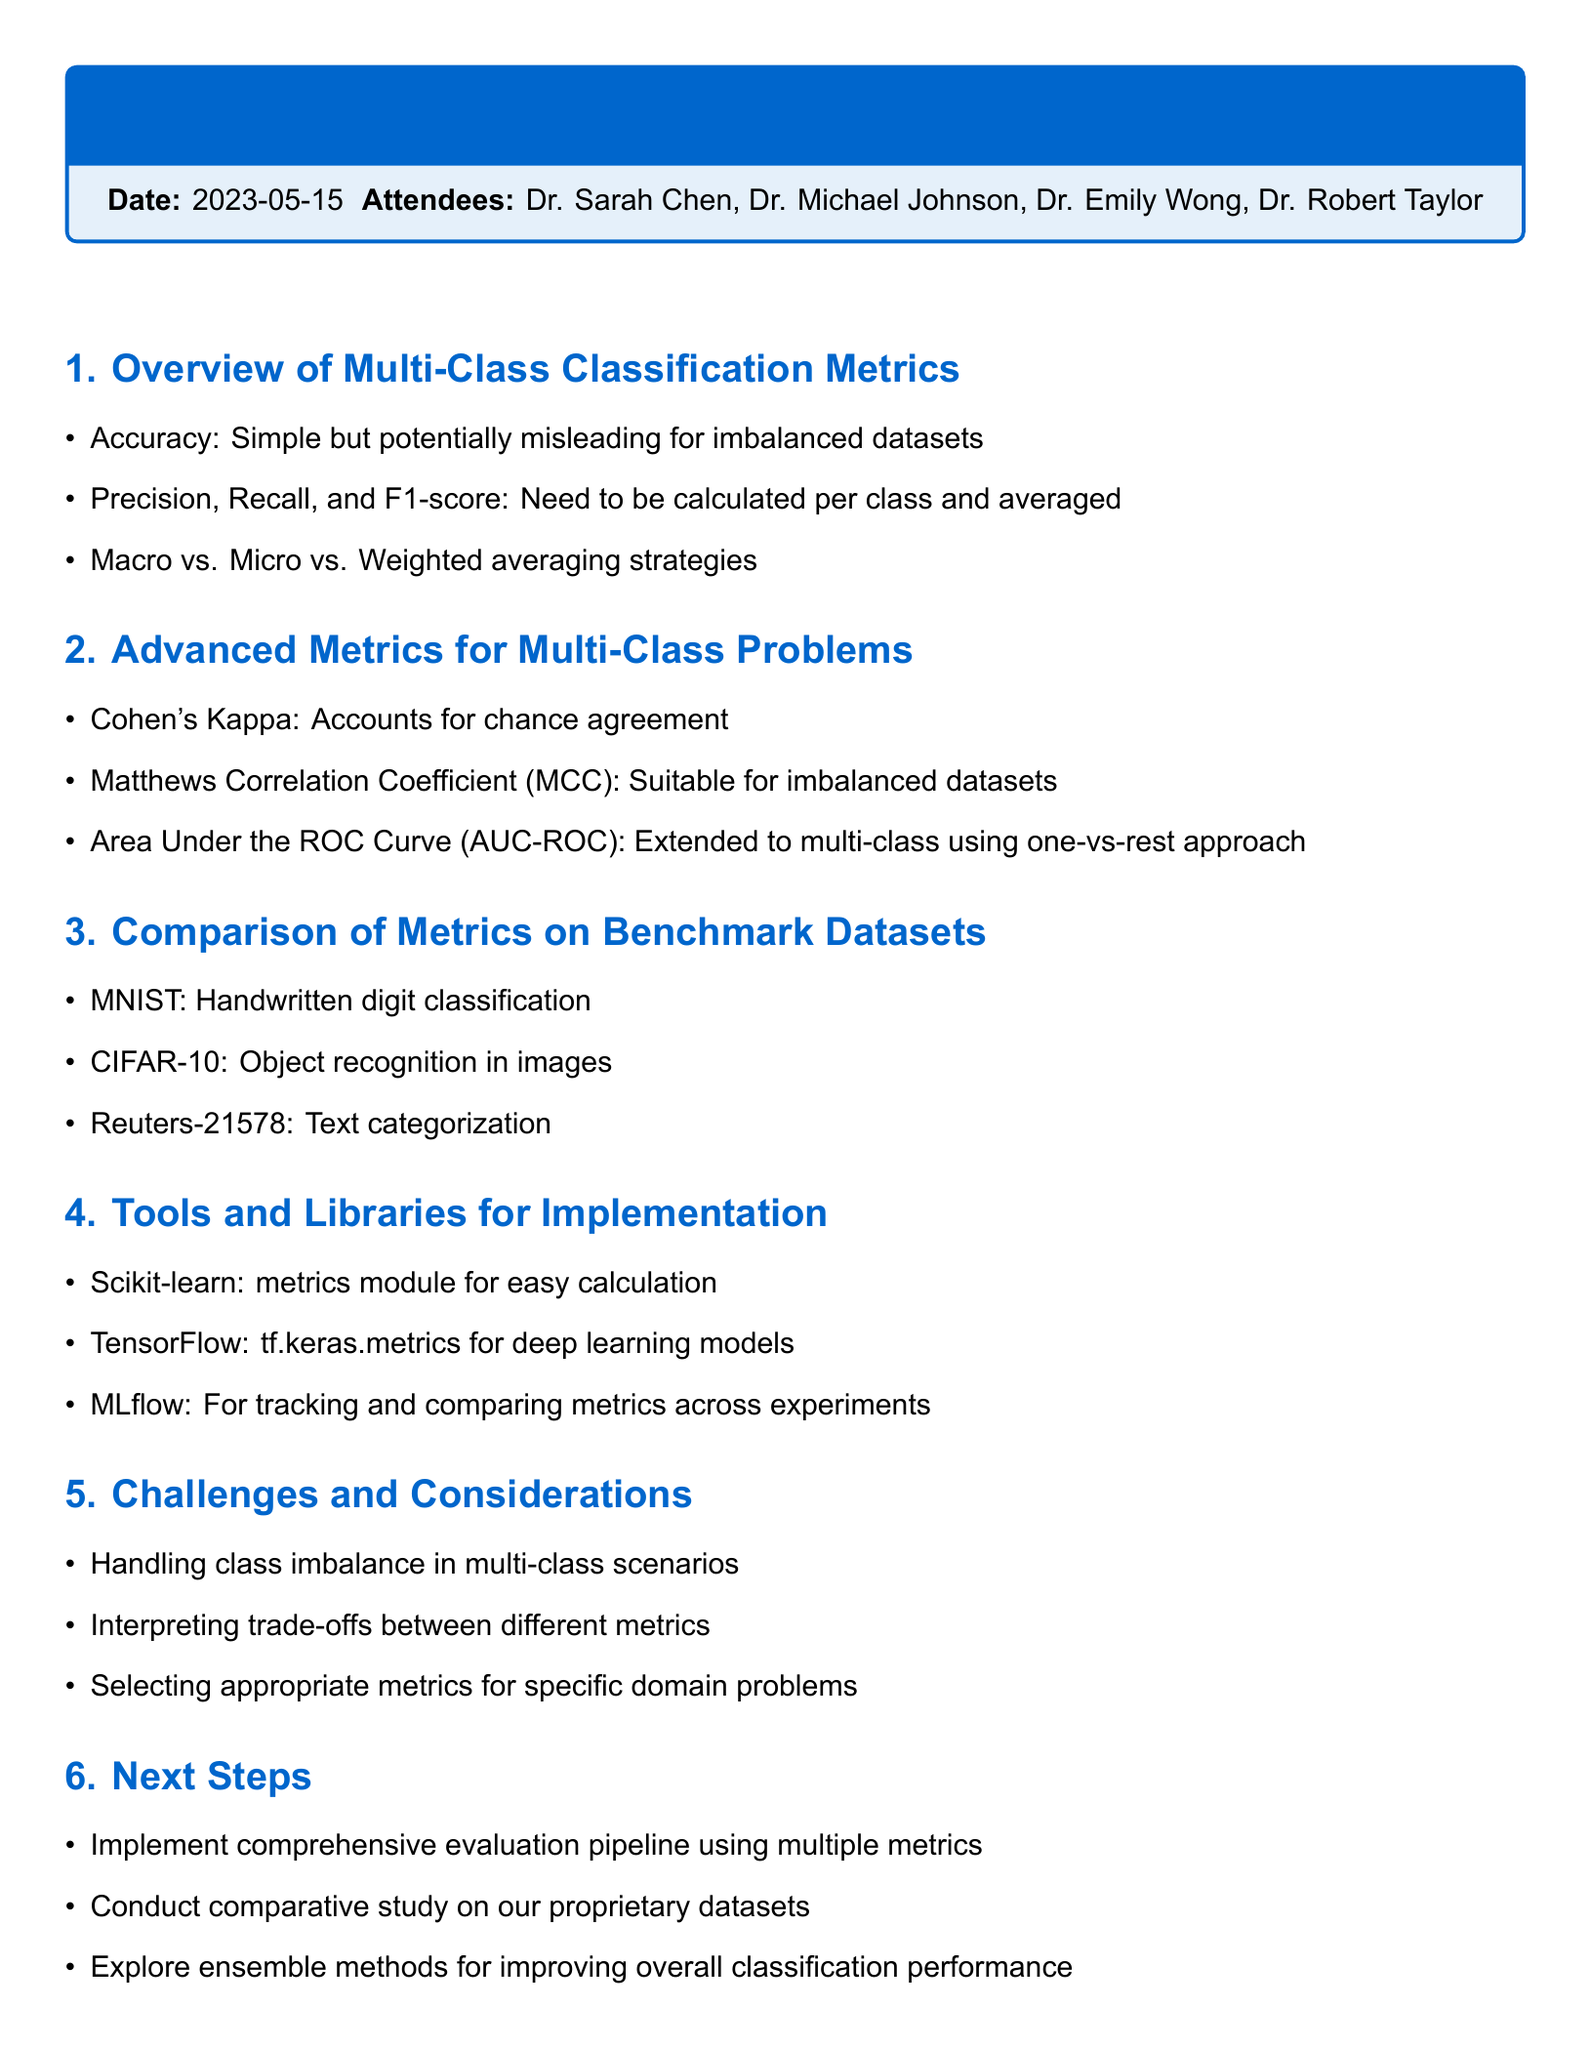What is the date of the meeting? The date of the meeting is mentioned clearly in the document.
Answer: 2023-05-15 Who is the AI Research Lead? The name and title of the AI Research Lead is listed in the attendees section.
Answer: Dr. Sarah Chen What are the advanced metrics discussed for multi-class problems? The document lists specific metrics under the advanced metrics section for multi-class problems.
Answer: Cohen's Kappa, Matthews Correlation Coefficient, Area Under the ROC Curve What benchmark dataset is used for text categorization? The document provides specific datasets used for comparison, including the one applied for text categorization.
Answer: Reuters-21578 What is one of the challenges mentioned regarding multi-class scenarios? The document outlines specific challenges faced in multi-class classification under the challenges section.
Answer: Handling class imbalance What is the next step related to performance metrics? The next steps outlined in the meeting include implementing a specific task using performance metrics.
Answer: Implement comprehensive evaluation pipeline What tools are suggested for metric calculation? The document lists various tools and libraries available for calculating metrics in multi-class classification.
Answer: Scikit-learn, TensorFlow, MLflow How many attendees were present at the meeting? The number of attendees is a straightforward retrieval from the document's attendee list.
Answer: Four 